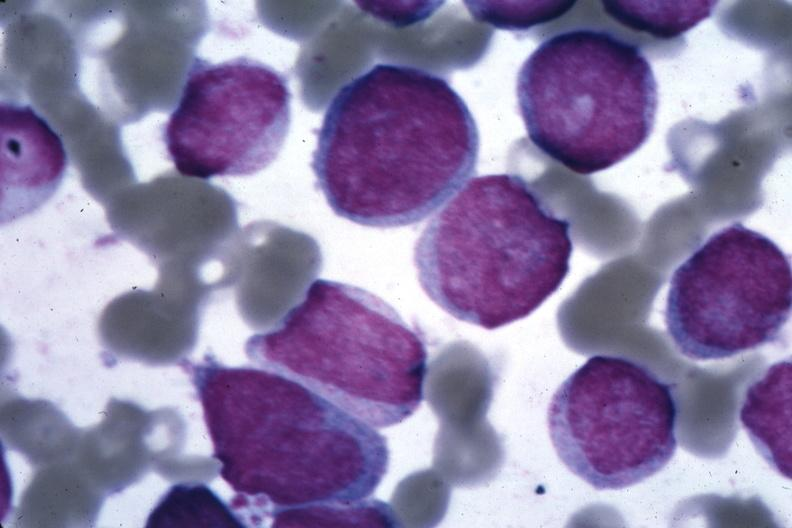s oil wrights cells diagnosed?
Answer the question using a single word or phrase. Yes 